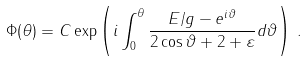Convert formula to latex. <formula><loc_0><loc_0><loc_500><loc_500>\Phi ( \theta ) = C \exp \left ( i \int _ { 0 } ^ { \theta } \frac { E / g - e ^ { i \vartheta } } { 2 \cos \vartheta + 2 + \varepsilon } d \vartheta \right ) \, .</formula> 